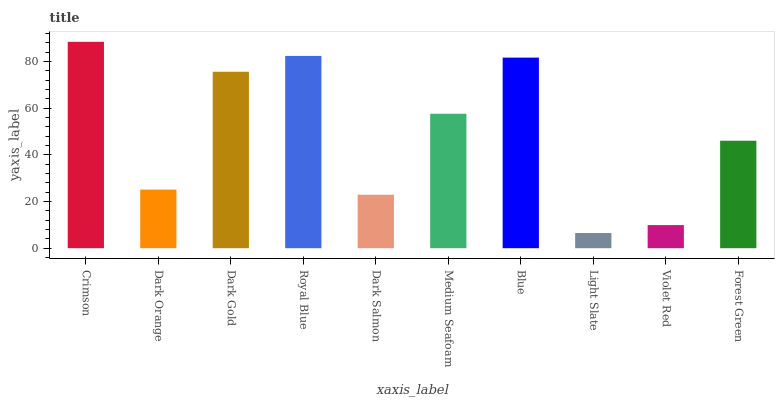Is Light Slate the minimum?
Answer yes or no. Yes. Is Crimson the maximum?
Answer yes or no. Yes. Is Dark Orange the minimum?
Answer yes or no. No. Is Dark Orange the maximum?
Answer yes or no. No. Is Crimson greater than Dark Orange?
Answer yes or no. Yes. Is Dark Orange less than Crimson?
Answer yes or no. Yes. Is Dark Orange greater than Crimson?
Answer yes or no. No. Is Crimson less than Dark Orange?
Answer yes or no. No. Is Medium Seafoam the high median?
Answer yes or no. Yes. Is Forest Green the low median?
Answer yes or no. Yes. Is Dark Orange the high median?
Answer yes or no. No. Is Dark Salmon the low median?
Answer yes or no. No. 